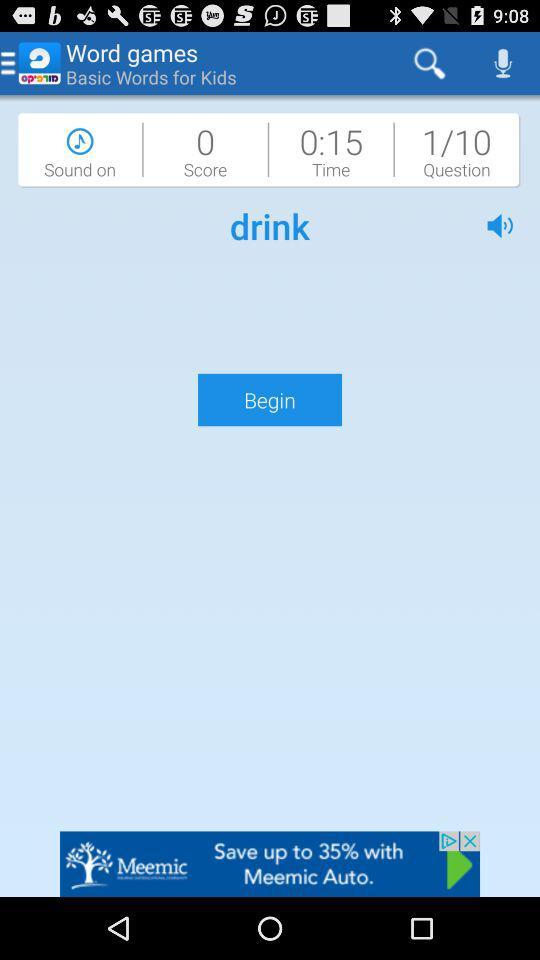What is the time? The time is 15 seconds. 